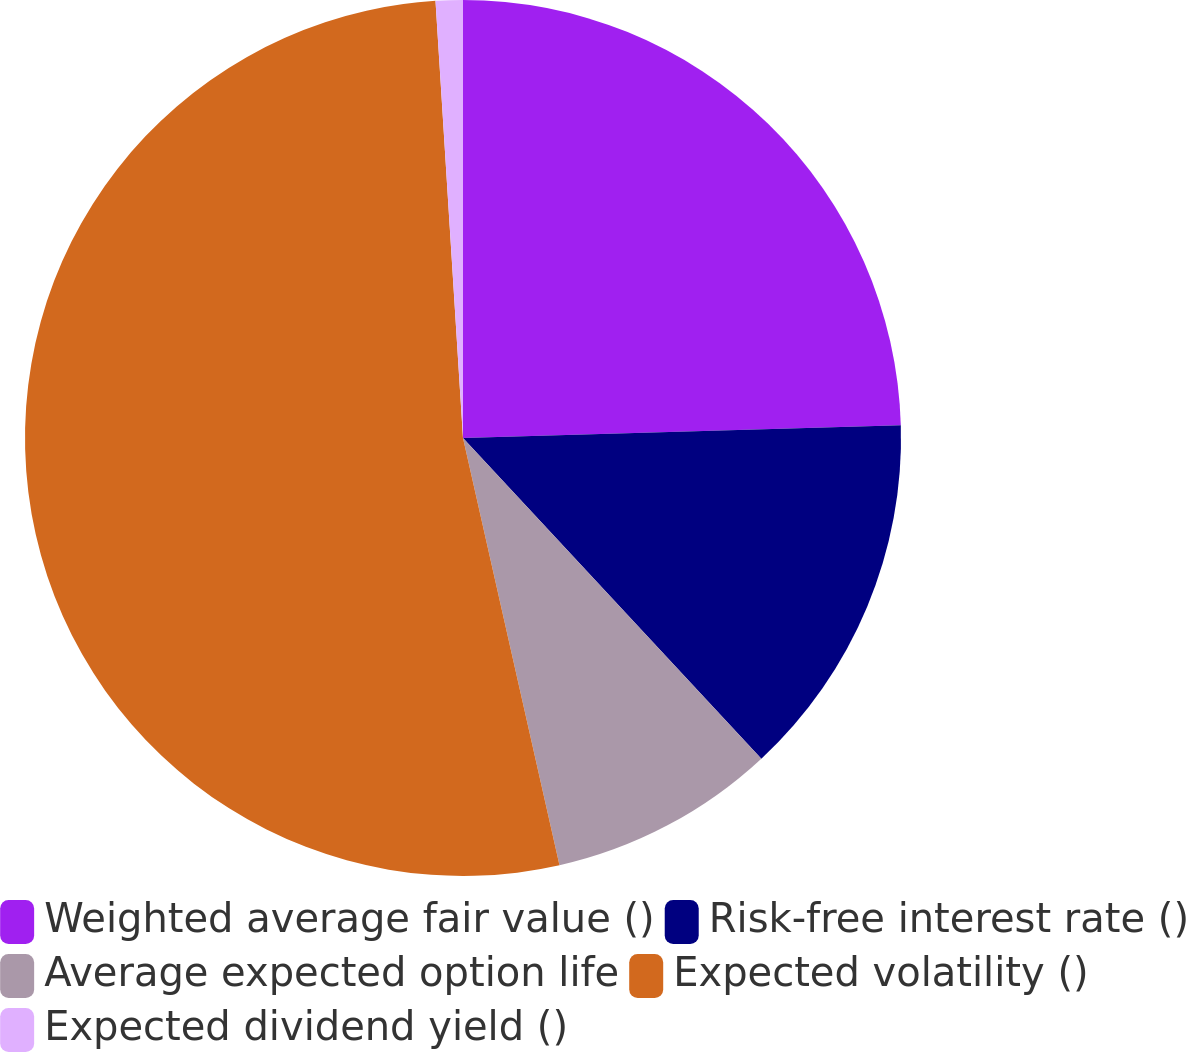Convert chart. <chart><loc_0><loc_0><loc_500><loc_500><pie_chart><fcel>Weighted average fair value ()<fcel>Risk-free interest rate ()<fcel>Average expected option life<fcel>Expected volatility ()<fcel>Expected dividend yield ()<nl><fcel>24.53%<fcel>13.54%<fcel>8.39%<fcel>52.53%<fcel>1.0%<nl></chart> 